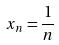<formula> <loc_0><loc_0><loc_500><loc_500>x _ { n } = \frac { 1 } { n }</formula> 